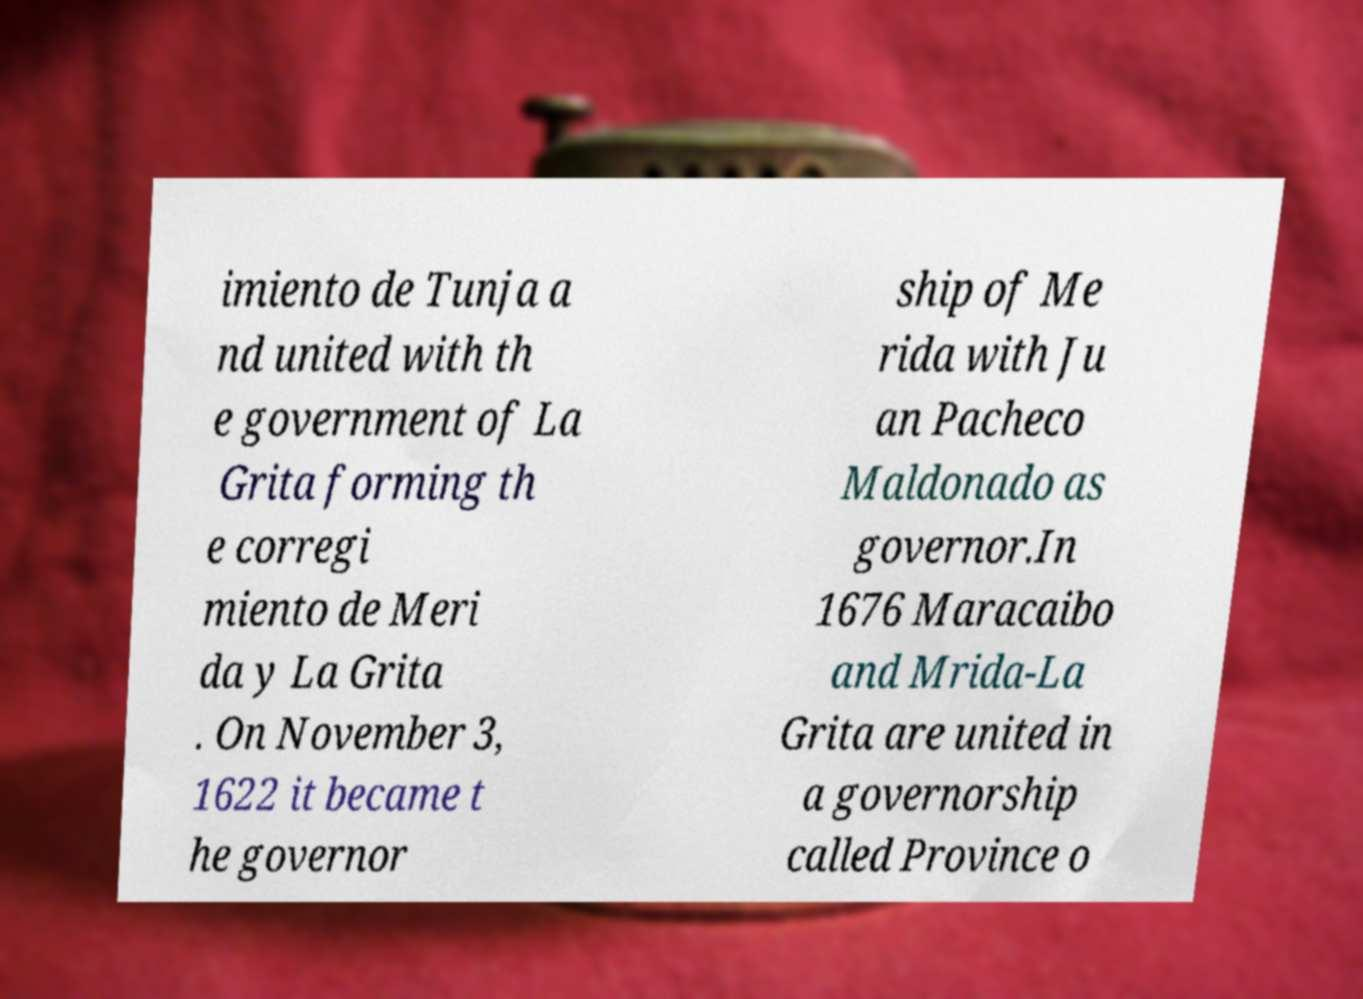Please identify and transcribe the text found in this image. imiento de Tunja a nd united with th e government of La Grita forming th e corregi miento de Meri da y La Grita . On November 3, 1622 it became t he governor ship of Me rida with Ju an Pacheco Maldonado as governor.In 1676 Maracaibo and Mrida-La Grita are united in a governorship called Province o 